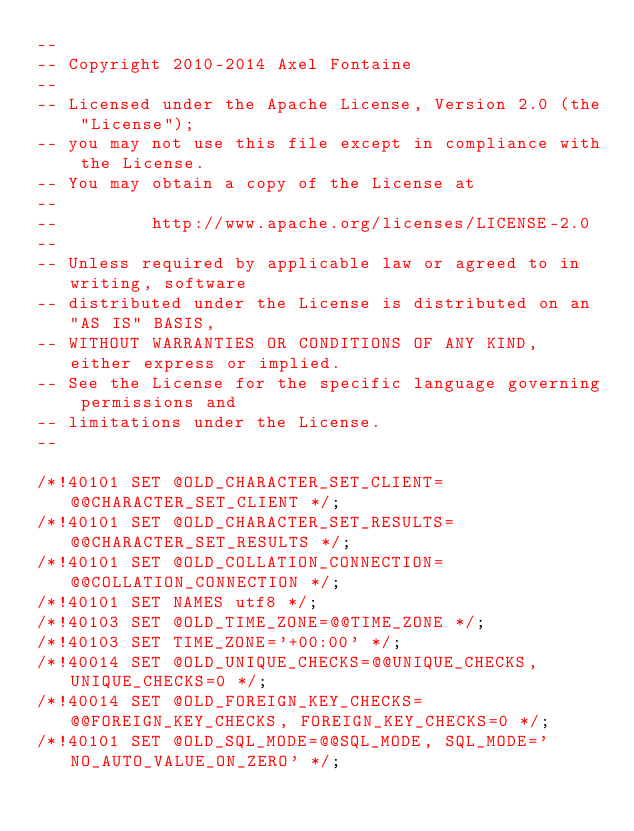<code> <loc_0><loc_0><loc_500><loc_500><_SQL_>--
-- Copyright 2010-2014 Axel Fontaine
--
-- Licensed under the Apache License, Version 2.0 (the "License");
-- you may not use this file except in compliance with the License.
-- You may obtain a copy of the License at
--
--         http://www.apache.org/licenses/LICENSE-2.0
--
-- Unless required by applicable law or agreed to in writing, software
-- distributed under the License is distributed on an "AS IS" BASIS,
-- WITHOUT WARRANTIES OR CONDITIONS OF ANY KIND, either express or implied.
-- See the License for the specific language governing permissions and
-- limitations under the License.
--

/*!40101 SET @OLD_CHARACTER_SET_CLIENT=@@CHARACTER_SET_CLIENT */;
/*!40101 SET @OLD_CHARACTER_SET_RESULTS=@@CHARACTER_SET_RESULTS */;
/*!40101 SET @OLD_COLLATION_CONNECTION=@@COLLATION_CONNECTION */;
/*!40101 SET NAMES utf8 */;
/*!40103 SET @OLD_TIME_ZONE=@@TIME_ZONE */;
/*!40103 SET TIME_ZONE='+00:00' */;
/*!40014 SET @OLD_UNIQUE_CHECKS=@@UNIQUE_CHECKS, UNIQUE_CHECKS=0 */;
/*!40014 SET @OLD_FOREIGN_KEY_CHECKS=@@FOREIGN_KEY_CHECKS, FOREIGN_KEY_CHECKS=0 */;
/*!40101 SET @OLD_SQL_MODE=@@SQL_MODE, SQL_MODE='NO_AUTO_VALUE_ON_ZERO' */;</code> 